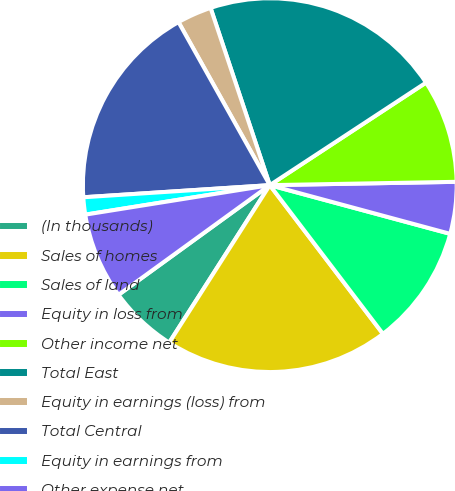Convert chart. <chart><loc_0><loc_0><loc_500><loc_500><pie_chart><fcel>(In thousands)<fcel>Sales of homes<fcel>Sales of land<fcel>Equity in loss from<fcel>Other income net<fcel>Total East<fcel>Equity in earnings (loss) from<fcel>Total Central<fcel>Equity in earnings from<fcel>Other expense net<nl><fcel>5.97%<fcel>19.4%<fcel>10.45%<fcel>4.48%<fcel>8.96%<fcel>20.89%<fcel>2.99%<fcel>17.91%<fcel>1.49%<fcel>7.46%<nl></chart> 